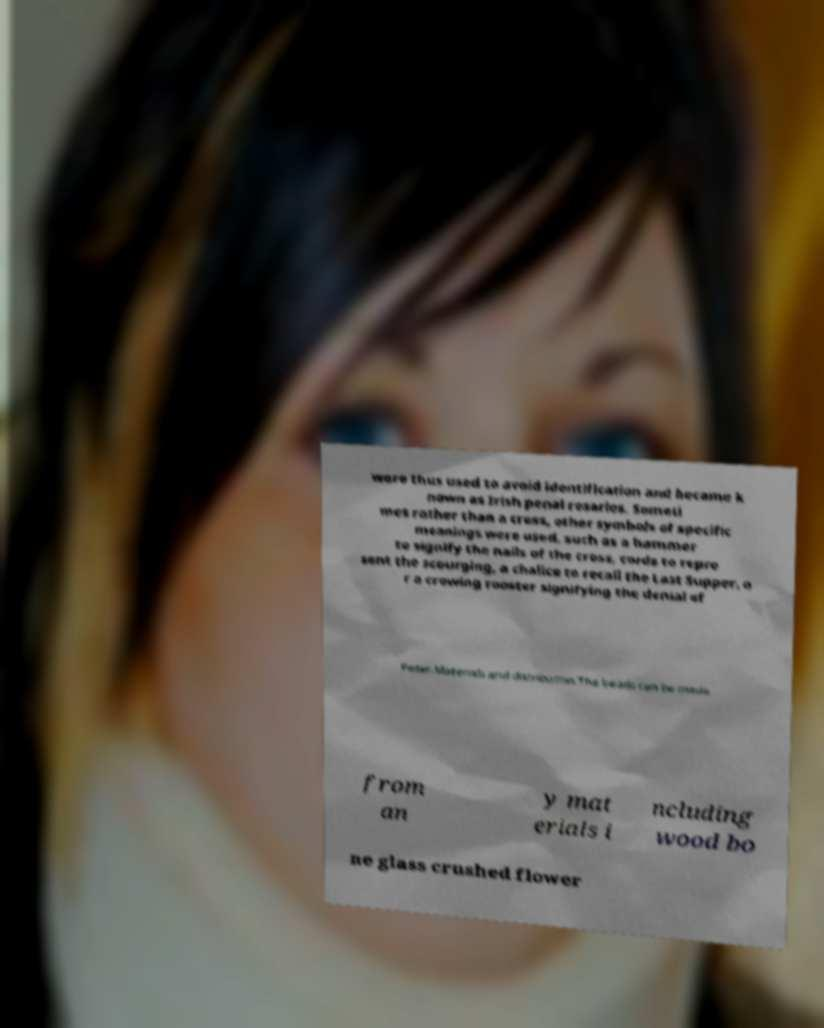Could you extract and type out the text from this image? were thus used to avoid identification and became k nown as Irish penal rosaries. Someti mes rather than a cross, other symbols of specific meanings were used, such as a hammer to signify the nails of the cross, cords to repre sent the scourging, a chalice to recall the Last Supper, o r a crowing rooster signifying the denial of Peter.Materials and distribution.The beads can be made from an y mat erials i ncluding wood bo ne glass crushed flower 